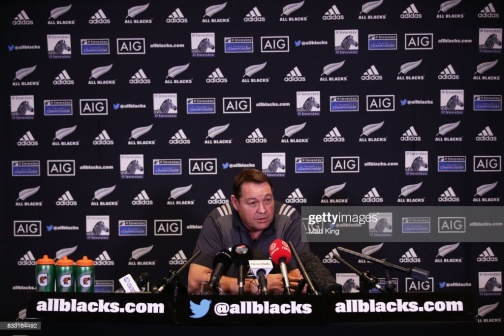Can you tell me what 'allblacks.com' refers to in this context? The 'allblacks.com' reference in the image is indicative of the official website for the All Blacks, which is the nickname for New Zealand's national rugby union team. This context likely places the man in the role of a team coach, player, or another official figure associated with the team and the sport of rugby. 